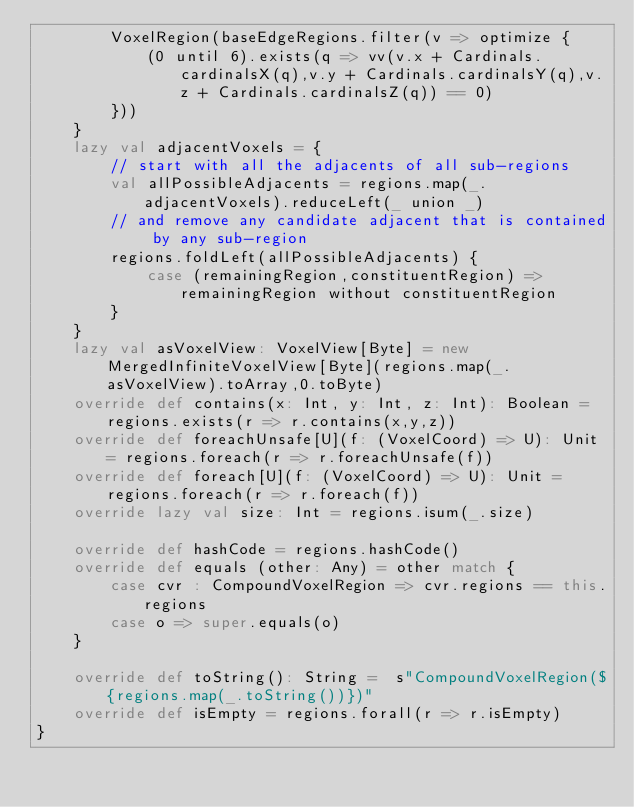Convert code to text. <code><loc_0><loc_0><loc_500><loc_500><_Scala_>		VoxelRegion(baseEdgeRegions.filter(v => optimize {
			(0 until 6).exists(q => vv(v.x + Cardinals.cardinalsX(q),v.y + Cardinals.cardinalsY(q),v.z + Cardinals.cardinalsZ(q)) == 0)
		}))
	}
	lazy val adjacentVoxels = {
		// start with all the adjacents of all sub-regions
		val allPossibleAdjacents = regions.map(_.adjacentVoxels).reduceLeft(_ union _)
		// and remove any candidate adjacent that is contained by any sub-region
		regions.foldLeft(allPossibleAdjacents) {
			case (remainingRegion,constituentRegion) => remainingRegion without constituentRegion
		}
	}
	lazy val asVoxelView: VoxelView[Byte] = new MergedInfiniteVoxelView[Byte](regions.map(_.asVoxelView).toArray,0.toByte)
	override def contains(x: Int, y: Int, z: Int): Boolean = regions.exists(r => r.contains(x,y,z))
	override def foreachUnsafe[U](f: (VoxelCoord) => U): Unit = regions.foreach(r => r.foreachUnsafe(f))
	override def foreach[U](f: (VoxelCoord) => U): Unit = regions.foreach(r => r.foreach(f))
	override lazy val size: Int = regions.isum(_.size)

	override def hashCode = regions.hashCode()
	override def equals (other: Any) = other match {
		case cvr : CompoundVoxelRegion => cvr.regions == this.regions
		case o => super.equals(o)
	}

	override def toString(): String =  s"CompoundVoxelRegion(${regions.map(_.toString())})"
	override def isEmpty = regions.forall(r => r.isEmpty)
}
</code> 